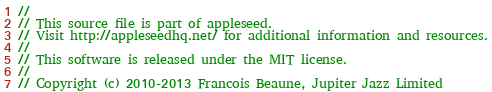Convert code to text. <code><loc_0><loc_0><loc_500><loc_500><_C++_>
//
// This source file is part of appleseed.
// Visit http://appleseedhq.net/ for additional information and resources.
//
// This software is released under the MIT license.
//
// Copyright (c) 2010-2013 Francois Beaune, Jupiter Jazz Limited</code> 